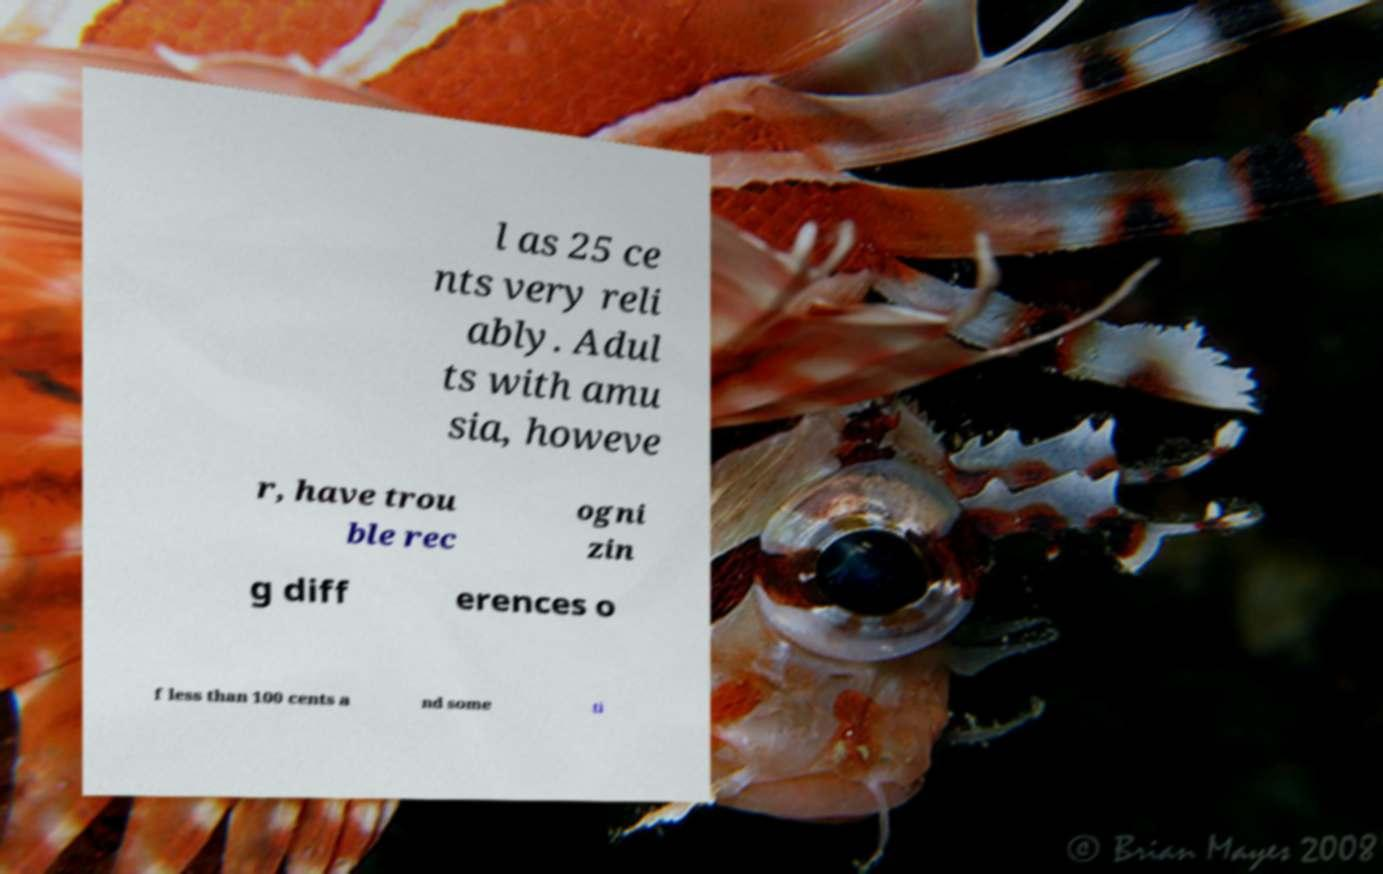Can you read and provide the text displayed in the image?This photo seems to have some interesting text. Can you extract and type it out for me? l as 25 ce nts very reli ably. Adul ts with amu sia, howeve r, have trou ble rec ogni zin g diff erences o f less than 100 cents a nd some ti 